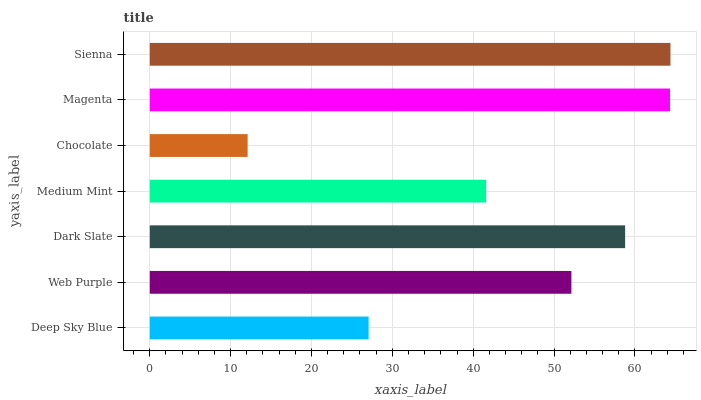Is Chocolate the minimum?
Answer yes or no. Yes. Is Sienna the maximum?
Answer yes or no. Yes. Is Web Purple the minimum?
Answer yes or no. No. Is Web Purple the maximum?
Answer yes or no. No. Is Web Purple greater than Deep Sky Blue?
Answer yes or no. Yes. Is Deep Sky Blue less than Web Purple?
Answer yes or no. Yes. Is Deep Sky Blue greater than Web Purple?
Answer yes or no. No. Is Web Purple less than Deep Sky Blue?
Answer yes or no. No. Is Web Purple the high median?
Answer yes or no. Yes. Is Web Purple the low median?
Answer yes or no. Yes. Is Magenta the high median?
Answer yes or no. No. Is Deep Sky Blue the low median?
Answer yes or no. No. 